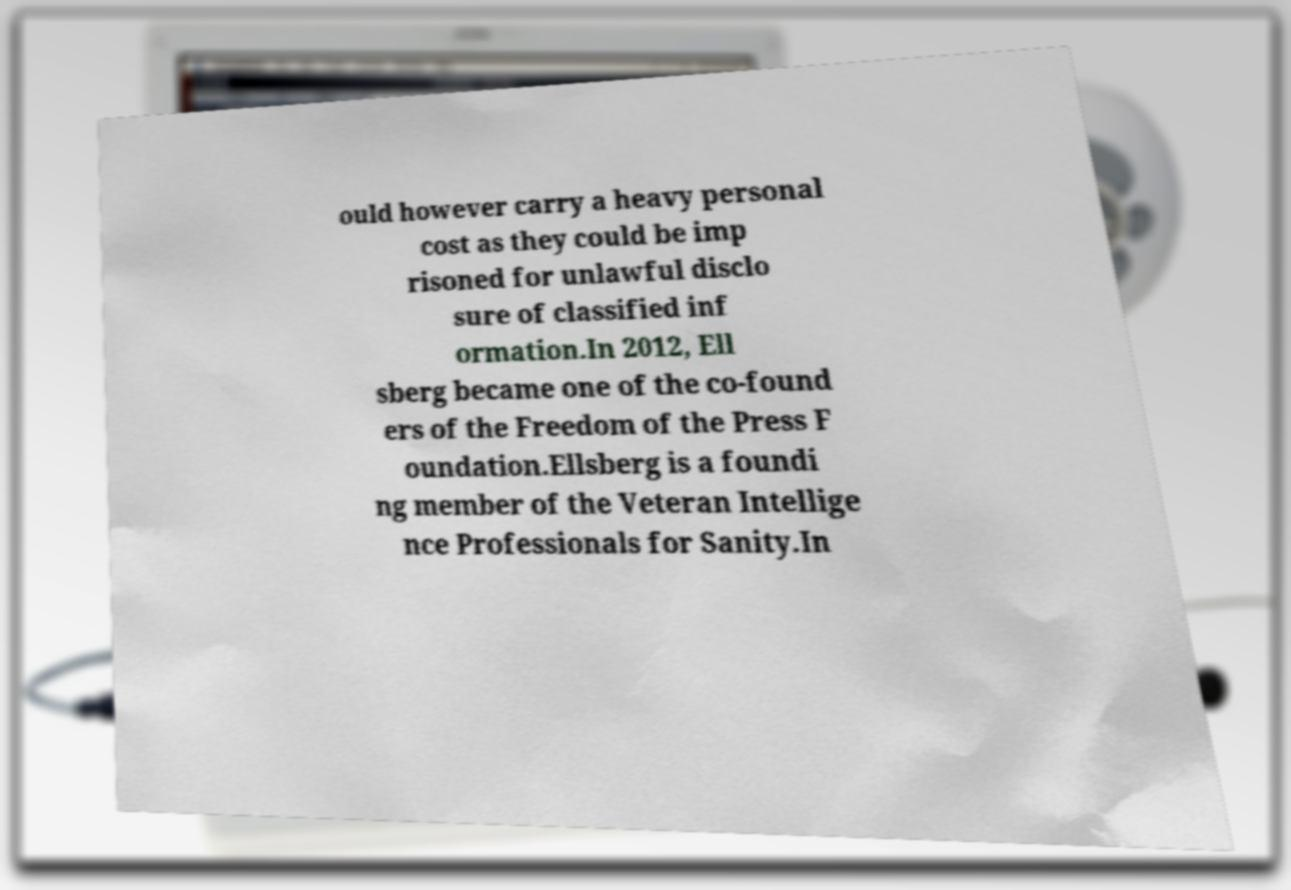What messages or text are displayed in this image? I need them in a readable, typed format. ould however carry a heavy personal cost as they could be imp risoned for unlawful disclo sure of classified inf ormation.In 2012, Ell sberg became one of the co-found ers of the Freedom of the Press F oundation.Ellsberg is a foundi ng member of the Veteran Intellige nce Professionals for Sanity.In 